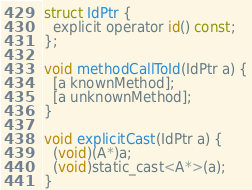<code> <loc_0><loc_0><loc_500><loc_500><_ObjectiveC_>struct IdPtr {
  explicit operator id() const;
};

void methodCallToId(IdPtr a) {
  [a knownMethod];
  [a unknownMethod];
}

void explicitCast(IdPtr a) {
  (void)(A*)a;
  (void)static_cast<A*>(a);
}
</code> 